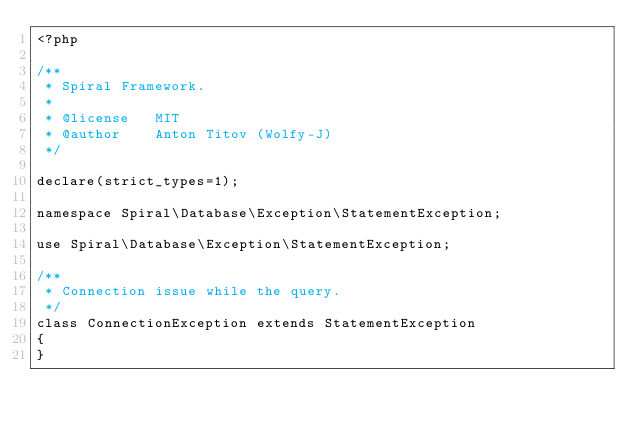Convert code to text. <code><loc_0><loc_0><loc_500><loc_500><_PHP_><?php

/**
 * Spiral Framework.
 *
 * @license   MIT
 * @author    Anton Titov (Wolfy-J)
 */

declare(strict_types=1);

namespace Spiral\Database\Exception\StatementException;

use Spiral\Database\Exception\StatementException;

/**
 * Connection issue while the query.
 */
class ConnectionException extends StatementException
{
}
</code> 